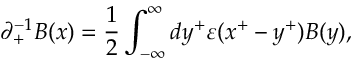Convert formula to latex. <formula><loc_0><loc_0><loc_500><loc_500>{ \partial } _ { + } ^ { - 1 } B ( x ) = \frac { 1 } { 2 } \int _ { - { \infty } } ^ { \infty } d y ^ { + } { \varepsilon } ( x ^ { + } - y ^ { + } ) B ( y ) ,</formula> 